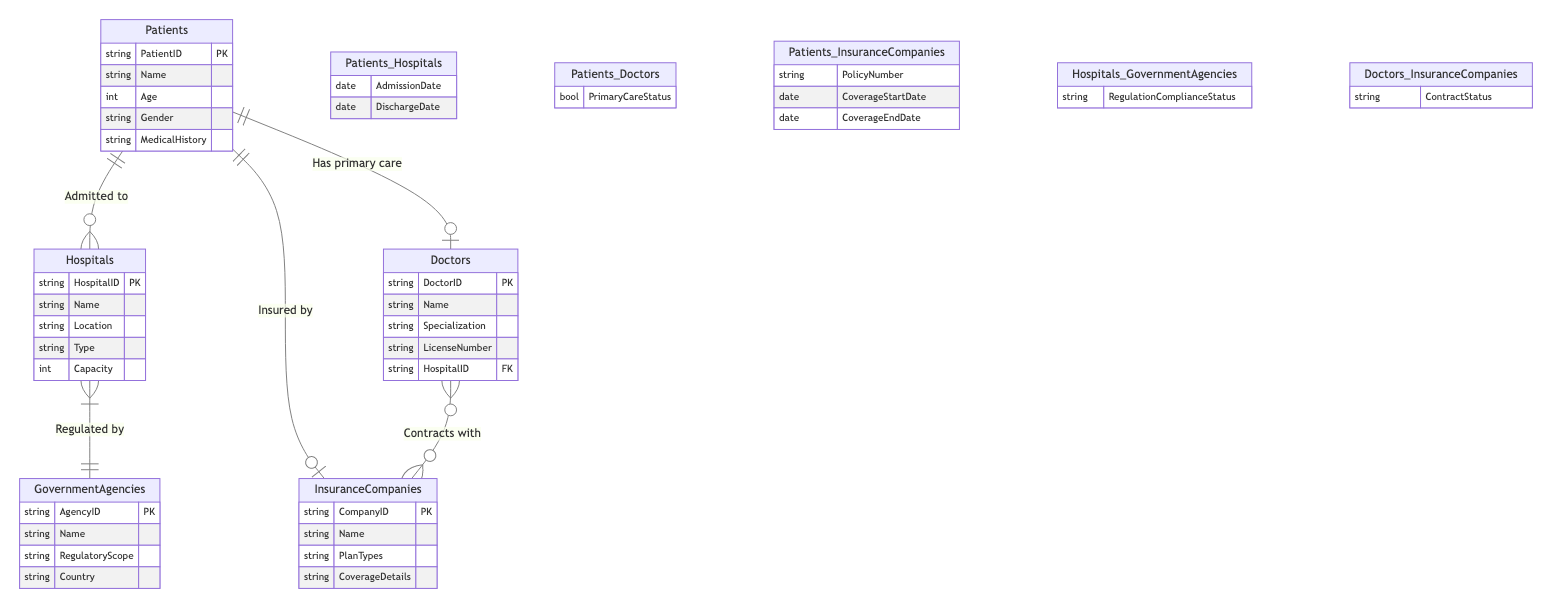What entities are represented in the diagram? The diagram includes five entities: Patients, Hospitals, Doctors, InsuranceCompanies, and GovernmentAgencies.
Answer: Patients, Hospitals, Doctors, InsuranceCompanies, GovernmentAgencies How many attributes does the Patients entity have? The Patients entity has five attributes: PatientID, Name, Age, Gender, and MedicalHistory.
Answer: 5 What type of relationship exists between Patients and Hospitals? The relationship type between Patients and Hospitals is many-to-many. This indicates that multiple patients can be admitted to multiple hospitals.
Answer: many-to-many What attribute is shared between the Doctors and InsuranceCompanies entities? The attribute shared in their relationship is ContractStatus. This attribute describes the relationship between doctors and the insurance companies they are contracted with.
Answer: ContractStatus Which entity is regulated by GovernmentAgencies? Hospitals are regulated by GovernmentAgencies, reflecting a regulatory relationship in the healthcare system.
Answer: Hospitals What is the primary role of GovernmentAgencies in the healthcare diagram? GovernmentAgencies serve a regulatory role, as indicated by their relationship with Hospitals, which shows that Hospitals must comply with regulations set by these agencies.
Answer: Regulatory role How do Patients connect with InsuranceCompanies? Patients are connected to InsuranceCompanies through a many-to-one relationship, meaning multiple patients can have the same insurance company but each patient typically has one primary insurance.
Answer: many-to-one What is the significance of the PrimaryCareStatus attribute in the Patients_Doctors relationship? The PrimaryCareStatus attribute signifies whether a patient has a primary care doctor, establishing a direct link between the patient and their healthcare provider.
Answer: Primary care status How many entities have a many-to-many relationship in the diagram? There are two many-to-many relationships in the diagram: one between Patients and Hospitals, and one between Doctors and InsuranceCompanies.
Answer: 2 What type of relationship exists between Doctors and InsuranceCompanies? The relationship type between Doctors and InsuranceCompanies is many-to-many, indicating that multiple doctors can contract with multiple insurance companies.
Answer: many-to-many 